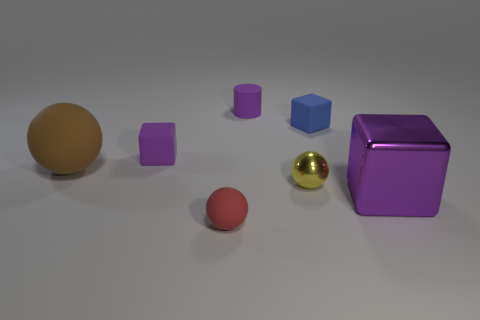Are there fewer tiny blue things that are to the right of the large purple block than tiny purple rubber objects that are to the right of the small metal thing?
Your response must be concise. No. What number of other large metal objects are the same shape as the yellow object?
Provide a short and direct response. 0. There is a purple cylinder that is the same material as the big brown sphere; what size is it?
Give a very brief answer. Small. What is the color of the big matte ball on the left side of the small object that is in front of the large metallic object?
Offer a terse response. Brown. Is the shape of the big brown matte object the same as the red matte thing that is in front of the tiny rubber cylinder?
Keep it short and to the point. Yes. How many red things are the same size as the yellow shiny ball?
Your answer should be very brief. 1. There is another big object that is the same shape as the blue object; what is its material?
Provide a succinct answer. Metal. There is a metallic thing in front of the yellow metal ball; is it the same color as the tiny matte thing behind the blue rubber object?
Offer a terse response. Yes. What is the shape of the small purple rubber object that is right of the purple rubber block?
Your response must be concise. Cylinder. What is the color of the matte cylinder?
Make the answer very short. Purple. 